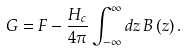<formula> <loc_0><loc_0><loc_500><loc_500>G = F - \frac { H _ { c } } { 4 \pi } \int _ { - \infty } ^ { \infty } d z \, B \left ( z \right ) .</formula> 